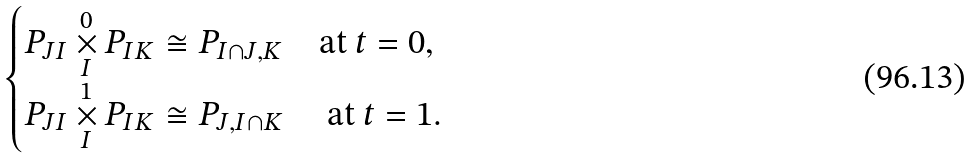Convert formula to latex. <formula><loc_0><loc_0><loc_500><loc_500>\begin{cases} P _ { J I } \underset { I } { \overset { 0 } { \times } } P _ { I K } \cong P _ { I \cap J , K } & \text {at $t=0$} , \\ P _ { J I } \underset { I } { \overset { 1 } { \times } } P _ { I K } \cong P _ { J , I \cap K } & \text { at $t=1$} . \end{cases}</formula> 